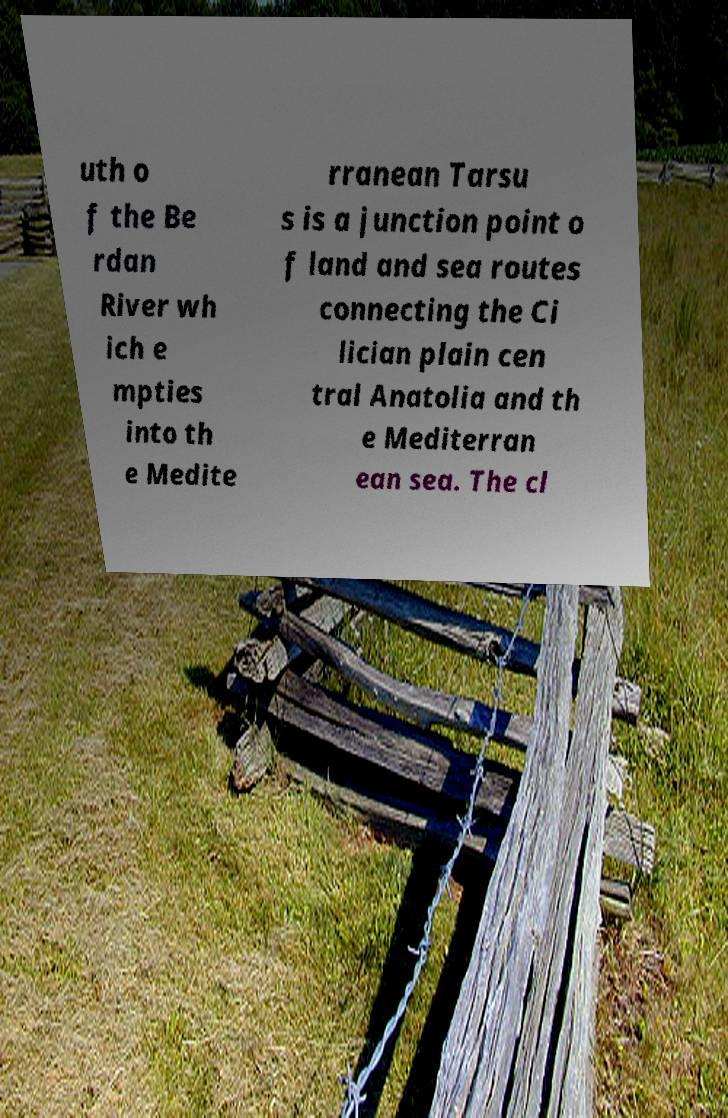For documentation purposes, I need the text within this image transcribed. Could you provide that? uth o f the Be rdan River wh ich e mpties into th e Medite rranean Tarsu s is a junction point o f land and sea routes connecting the Ci lician plain cen tral Anatolia and th e Mediterran ean sea. The cl 